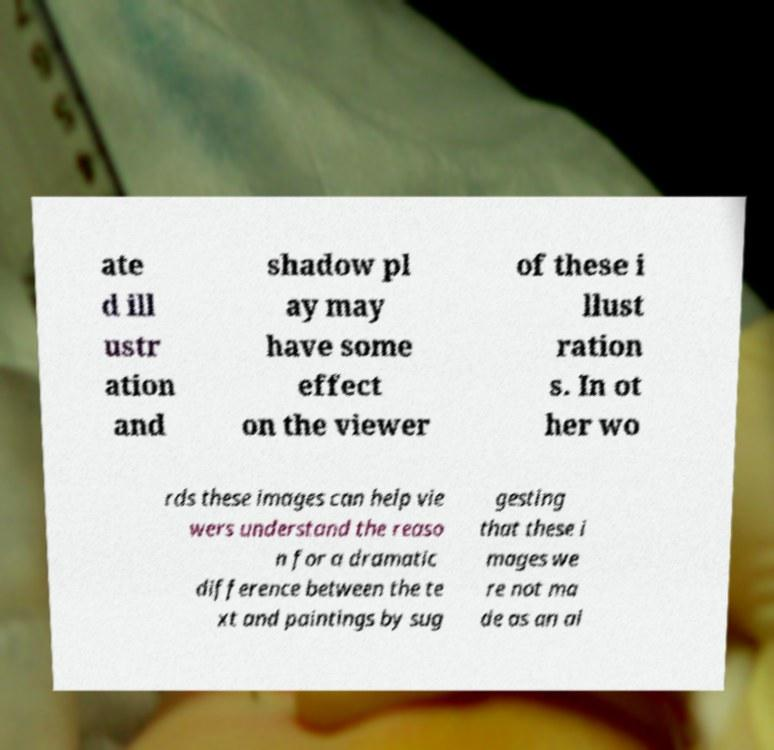Could you assist in decoding the text presented in this image and type it out clearly? ate d ill ustr ation and shadow pl ay may have some effect on the viewer of these i llust ration s. In ot her wo rds these images can help vie wers understand the reaso n for a dramatic difference between the te xt and paintings by sug gesting that these i mages we re not ma de as an ai 